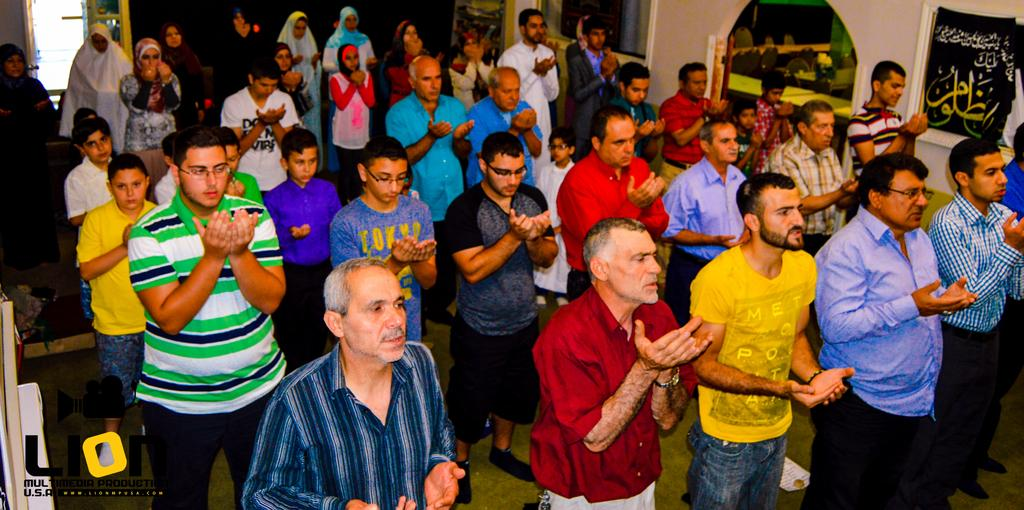What are the people in the image doing? The people in the image are praying. Can you describe the setting where the people are praying? The location appears to be a hall. Is there any text visible in the image? Yes, there is some text in the bottom left corner of the image. Did the earthquake cause any damage to the hall in the image? There is no mention of an earthquake in the provided facts, and therefore no such damage can be observed. Who is the creator of the hall in the image? The provided facts do not mention the creator of the hall, so it cannot be determined from the image. 